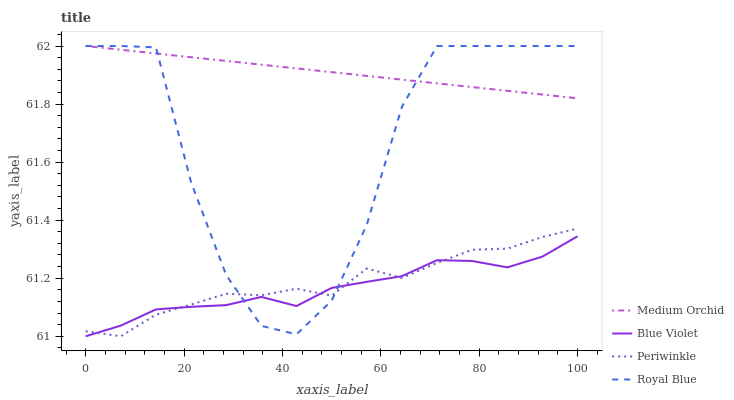Does Blue Violet have the minimum area under the curve?
Answer yes or no. Yes. Does Medium Orchid have the maximum area under the curve?
Answer yes or no. Yes. Does Periwinkle have the minimum area under the curve?
Answer yes or no. No. Does Periwinkle have the maximum area under the curve?
Answer yes or no. No. Is Medium Orchid the smoothest?
Answer yes or no. Yes. Is Royal Blue the roughest?
Answer yes or no. Yes. Is Periwinkle the smoothest?
Answer yes or no. No. Is Periwinkle the roughest?
Answer yes or no. No. Does Periwinkle have the lowest value?
Answer yes or no. Yes. Does Medium Orchid have the lowest value?
Answer yes or no. No. Does Medium Orchid have the highest value?
Answer yes or no. Yes. Does Periwinkle have the highest value?
Answer yes or no. No. Is Periwinkle less than Medium Orchid?
Answer yes or no. Yes. Is Medium Orchid greater than Periwinkle?
Answer yes or no. Yes. Does Royal Blue intersect Periwinkle?
Answer yes or no. Yes. Is Royal Blue less than Periwinkle?
Answer yes or no. No. Is Royal Blue greater than Periwinkle?
Answer yes or no. No. Does Periwinkle intersect Medium Orchid?
Answer yes or no. No. 